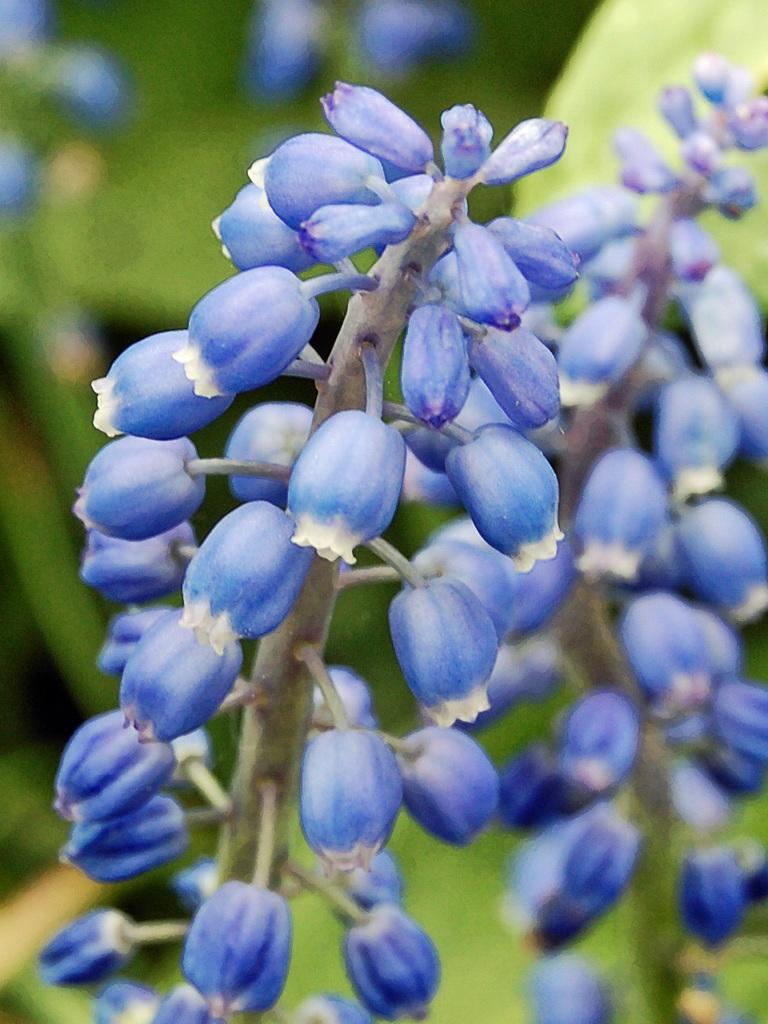What type of food can be seen in the image? There are fruits in the image. What type of disease is affecting the fruits in the image? There is no indication of any disease affecting the fruits in the image. What type of collar can be seen on the fruits in the image? There are no collars present on the fruits in the image. 